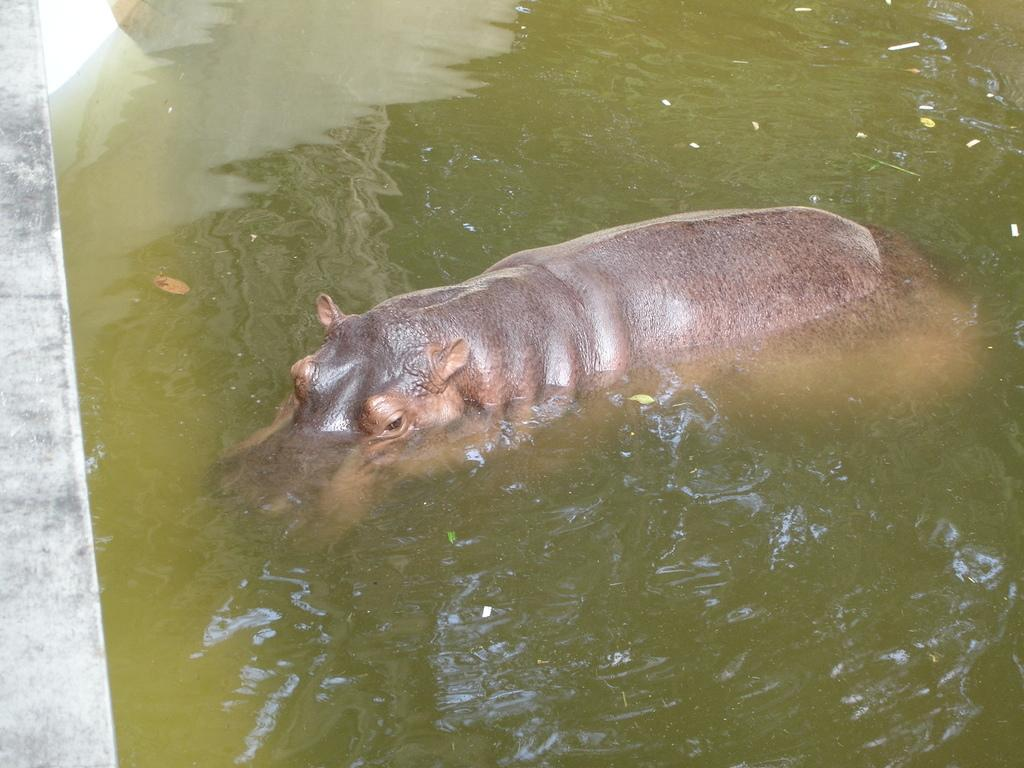What is the primary element visible in the image? There is water in the image. What type of animal can be seen in the image? There is a hippopotamus in the image. How many dolls are present in the image? There are no dolls present in the image; it features water and a hippopotamus. What type of error can be seen in the image? There is no error present in the image; it is a clear image of water and a hippopotamus. 